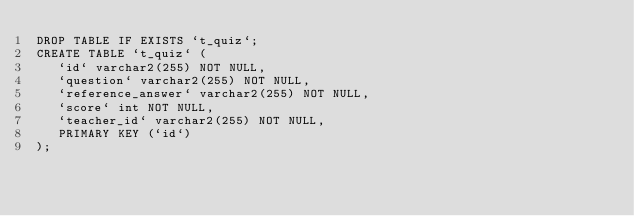<code> <loc_0><loc_0><loc_500><loc_500><_SQL_>DROP TABLE IF EXISTS `t_quiz`;
CREATE TABLE `t_quiz` (
   `id` varchar2(255) NOT NULL,
   `question` varchar2(255) NOT NULL,
   `reference_answer` varchar2(255) NOT NULL,
   `score` int NOT NULL,
   `teacher_id` varchar2(255) NOT NULL,
   PRIMARY KEY (`id`)
);</code> 